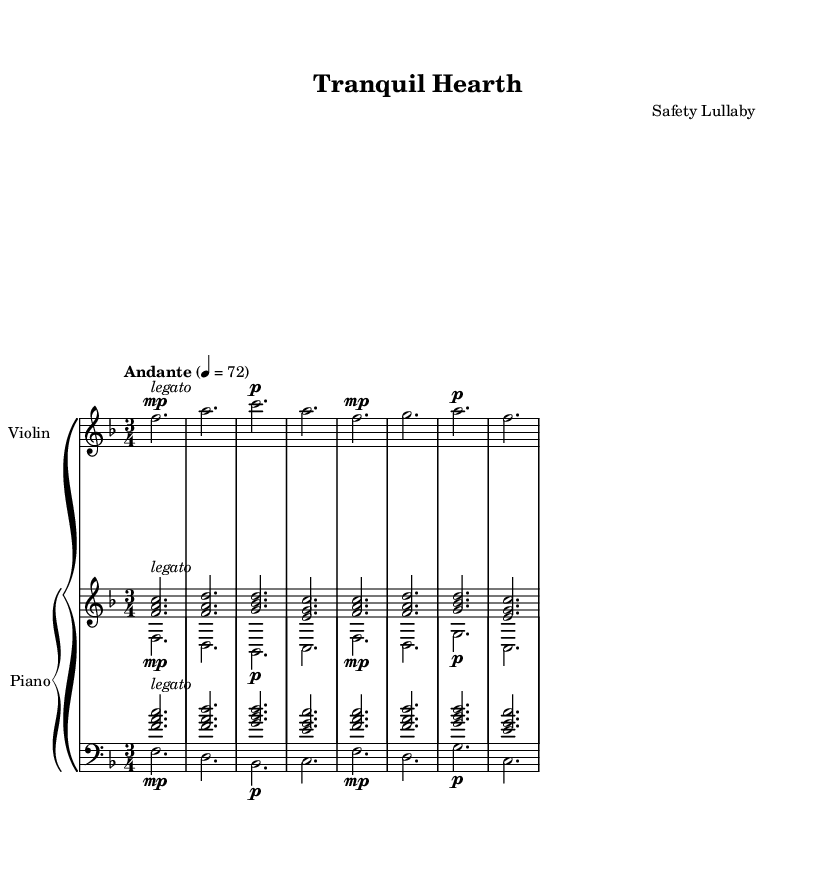What is the key signature of this music? The key signature is F major, which contains one flat (B flat). This can be determined by looking at the key signature symbol located at the beginning of the staff, indicating the notes affected by the flat.
Answer: F major What is the time signature of this music? The time signature is 3/4, which can be identified from the numbers placed at the beginning of the staff. It indicates that there are three beats in each measure and that the quarter note receives one beat.
Answer: 3/4 What is the tempo marking of this piece? The tempo marking is Andante, indicated in the score above the music, suggesting a moderately slow pace. The numerical metronome marking of 72 also supports this, specifying the beats per minute.
Answer: Andante How many measures are in the music? There are 8 measures, which can be tracked by counting the bar lines separating the segments of music on the staff. Each measure is delineated by vertical lines.
Answer: 8 What is the dynamic marking for the first violin note? The dynamic marking for the first violin note is mp (mezzo-piano), denoting a moderately soft volume. This can be found above the first note in the violin part, indicating the intended loudness for that note.
Answer: mp Which instruments are featured in this composition? The instruments featured are violin and piano, identifiable from the instrument names labeled at the beginning of each staff in the score. They indicate the specific parts assigned to each instrument.
Answer: Violin and piano What is the structure of the piano part? The structure includes two voices: upper and lower. This is indicated by the layout of the notation where two sets of staves are present, denoting the two distinct lines of melody and harmony in the piano part.
Answer: Upper and lower voices 